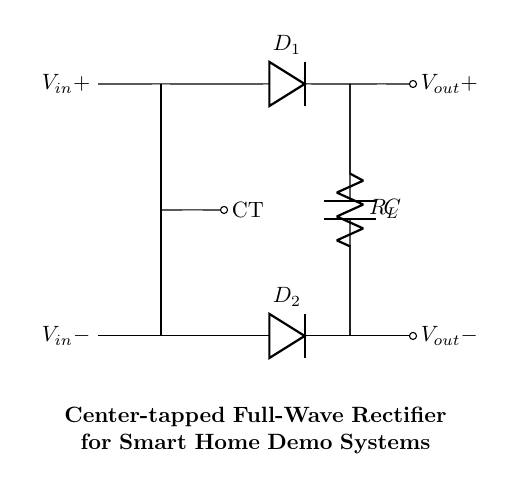What type of rectifier is shown in the circuit? The circuit illustrates a center-tapped full-wave rectifier as indicated by the layout of the diodes and the center tap of the transformer.
Answer: center-tapped full-wave rectifier What is the function of the diodes in this circuit? The diodes function as electronic switches that allow current to flow in one direction while blocking it in the opposite direction, thus converting AC to DC.
Answer: convert AC to DC How many diodes are present in this rectifier circuit? There are two diodes in the circuit, marked as D1 and D2, which are essential for full-wave rectification.
Answer: two diodes What is the role of the load resistor in this circuit? The load resistor R_L dissipates power and allows for the practical use of the rectified output voltage by providing a pathway for the current.
Answer: dissipate power What is the purpose of the capacitor in the circuit? The capacitor smooths the output voltage by charging during the peaks of the rectified signal and discharging during the lows, reducing voltage ripple.
Answer: smooth the output voltage What does the center tap of the transformer represent? The center tap represents a neutral or ground reference point, providing two equal voltage outputs for the full-wave rectification process.
Answer: neutral or ground reference point What is the significance of the output voltage in this circuit? The output voltage represents the DC voltage available for powering smart home systems, showcasing its role in providing stable energy.
Answer: stable DC voltage 